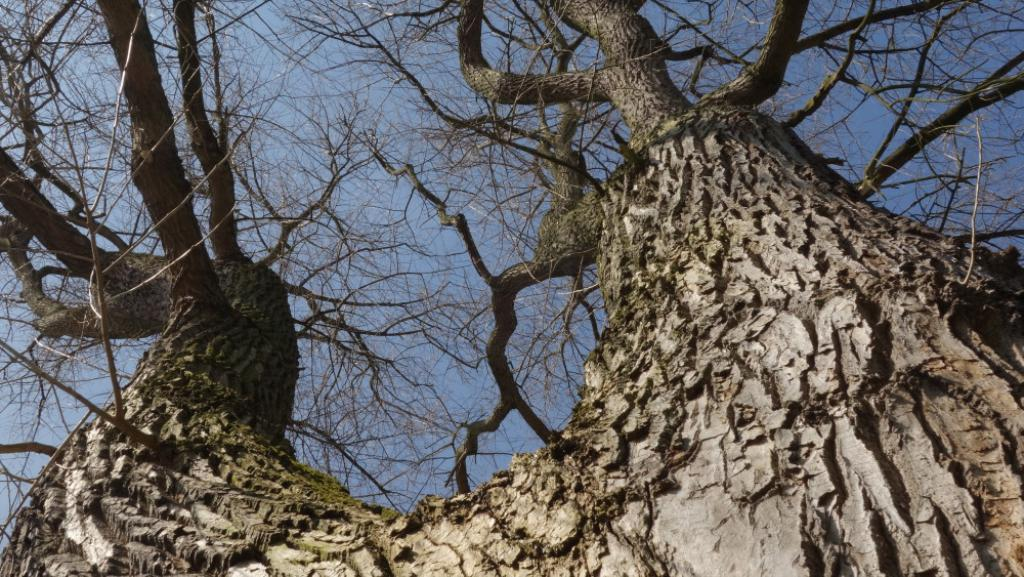What type of vegetation can be seen in the image? There are trees in the image. What part of the natural environment is visible in the image? The sky is visible in the image. What type of pot is used for magic in the image? There is no pot or magic present in the image; it only features trees and the sky. What time is displayed on the watch in the image? There is no watch present in the image. 